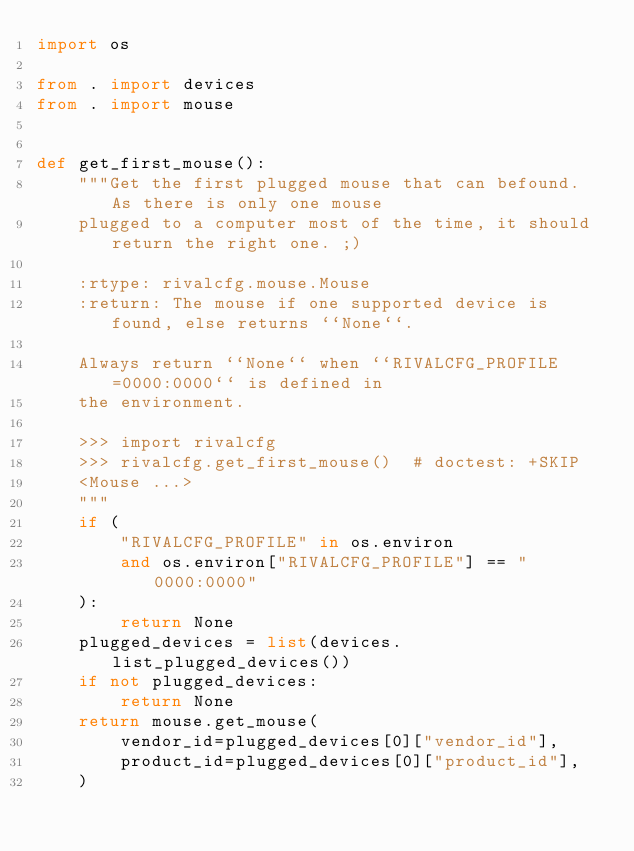<code> <loc_0><loc_0><loc_500><loc_500><_Python_>import os

from . import devices
from . import mouse


def get_first_mouse():
    """Get the first plugged mouse that can befound. As there is only one mouse
    plugged to a computer most of the time, it should return the right one. ;)

    :rtype: rivalcfg.mouse.Mouse
    :return: The mouse if one supported device is found, else returns ``None``.

    Always return ``None`` when ``RIVALCFG_PROFILE=0000:0000`` is defined in
    the environment.

    >>> import rivalcfg
    >>> rivalcfg.get_first_mouse()  # doctest: +SKIP
    <Mouse ...>
    """
    if (
        "RIVALCFG_PROFILE" in os.environ
        and os.environ["RIVALCFG_PROFILE"] == "0000:0000"
    ):
        return None
    plugged_devices = list(devices.list_plugged_devices())
    if not plugged_devices:
        return None
    return mouse.get_mouse(
        vendor_id=plugged_devices[0]["vendor_id"],
        product_id=plugged_devices[0]["product_id"],
    )
</code> 